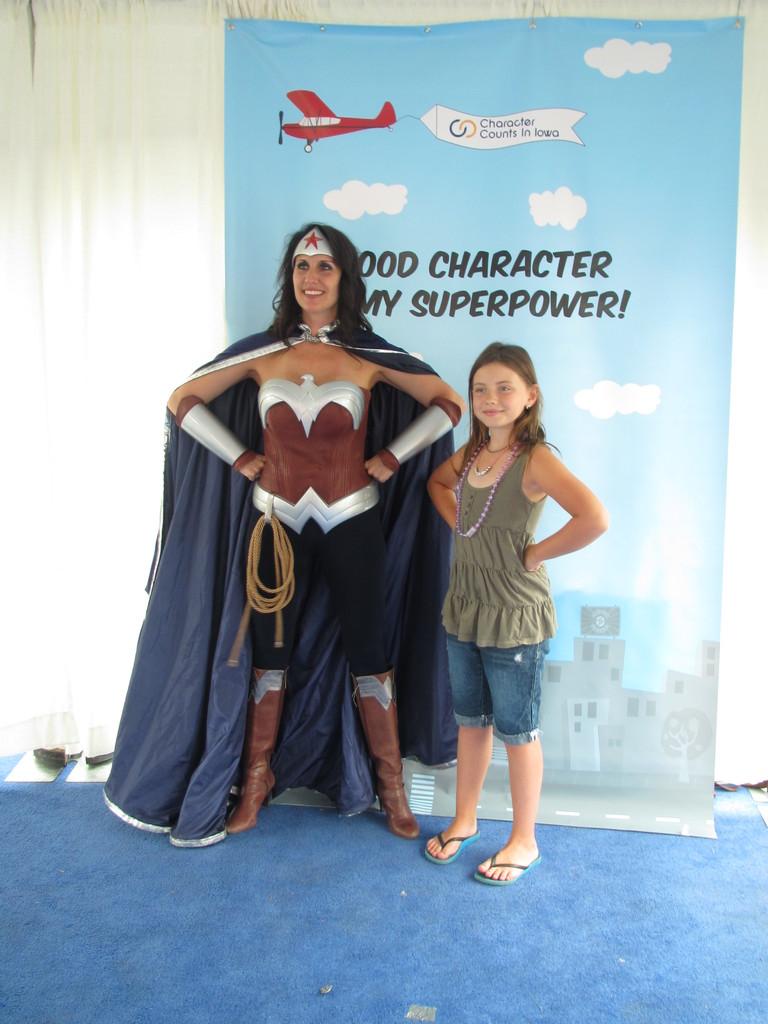What does it say her superpower is?
Make the answer very short. Good character. What is the name of the state on the sign the airplane is carrying?
Provide a short and direct response. Iowa. 